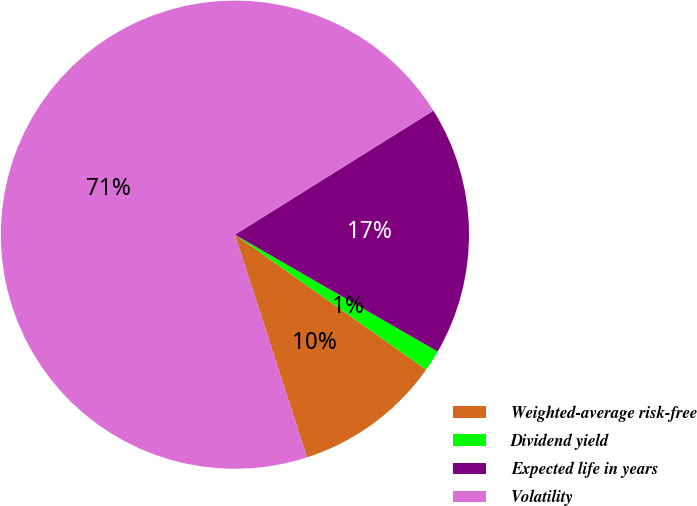Convert chart. <chart><loc_0><loc_0><loc_500><loc_500><pie_chart><fcel>Weighted-average risk-free<fcel>Dividend yield<fcel>Expected life in years<fcel>Volatility<nl><fcel>10.24%<fcel>1.46%<fcel>17.21%<fcel>71.09%<nl></chart> 